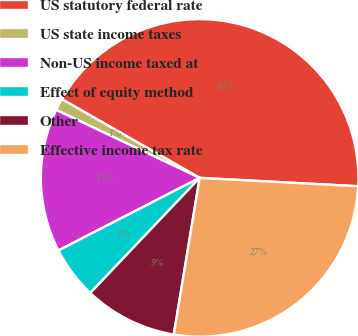Convert chart to OTSL. <chart><loc_0><loc_0><loc_500><loc_500><pie_chart><fcel>US statutory federal rate<fcel>US state income taxes<fcel>Non-US income taxed at<fcel>Effect of equity method<fcel>Other<fcel>Effective income tax rate<nl><fcel>42.58%<fcel>1.22%<fcel>14.6%<fcel>5.35%<fcel>9.49%<fcel>26.76%<nl></chart> 